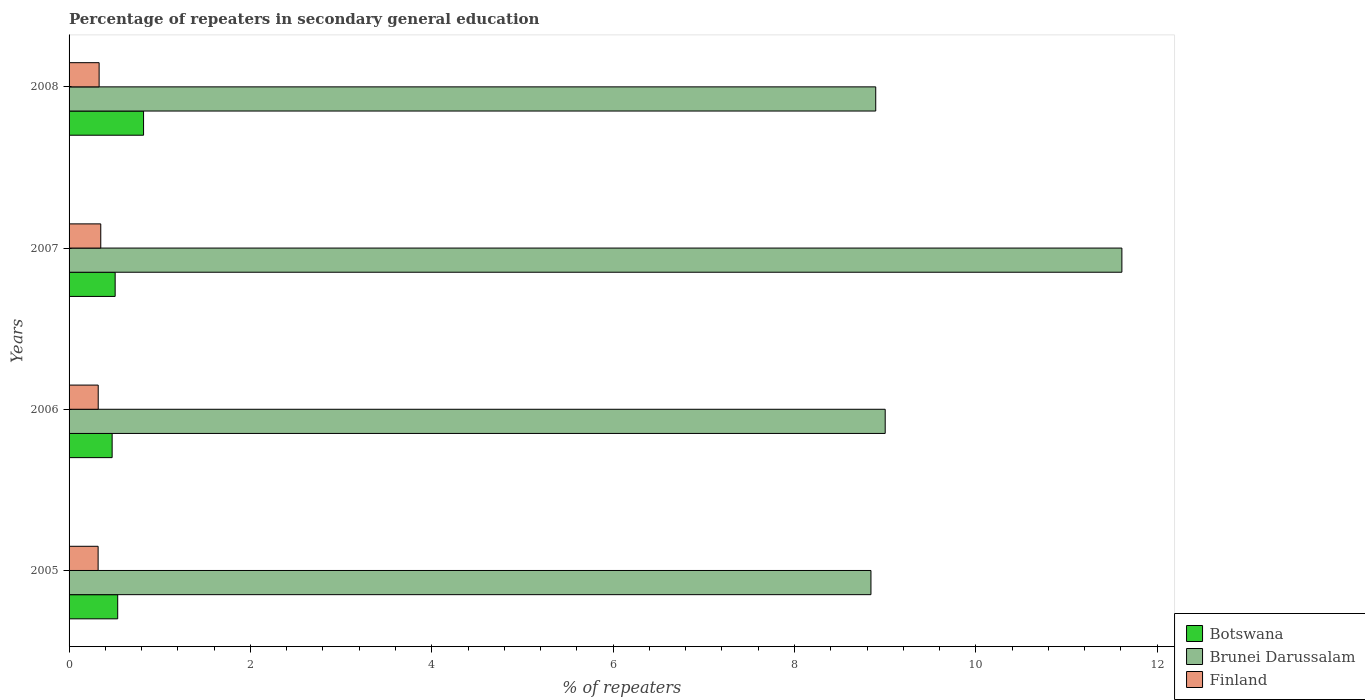How many different coloured bars are there?
Keep it short and to the point. 3. Are the number of bars on each tick of the Y-axis equal?
Your response must be concise. Yes. What is the label of the 3rd group of bars from the top?
Give a very brief answer. 2006. What is the percentage of repeaters in secondary general education in Botswana in 2005?
Give a very brief answer. 0.54. Across all years, what is the maximum percentage of repeaters in secondary general education in Brunei Darussalam?
Offer a very short reply. 11.61. Across all years, what is the minimum percentage of repeaters in secondary general education in Botswana?
Offer a terse response. 0.48. In which year was the percentage of repeaters in secondary general education in Botswana maximum?
Your answer should be compact. 2008. What is the total percentage of repeaters in secondary general education in Finland in the graph?
Your response must be concise. 1.32. What is the difference between the percentage of repeaters in secondary general education in Botswana in 2006 and that in 2008?
Make the answer very short. -0.35. What is the difference between the percentage of repeaters in secondary general education in Finland in 2005 and the percentage of repeaters in secondary general education in Brunei Darussalam in 2008?
Your answer should be compact. -8.58. What is the average percentage of repeaters in secondary general education in Brunei Darussalam per year?
Your response must be concise. 9.59. In the year 2008, what is the difference between the percentage of repeaters in secondary general education in Finland and percentage of repeaters in secondary general education in Botswana?
Offer a terse response. -0.49. What is the ratio of the percentage of repeaters in secondary general education in Finland in 2006 to that in 2007?
Give a very brief answer. 0.92. Is the difference between the percentage of repeaters in secondary general education in Finland in 2005 and 2006 greater than the difference between the percentage of repeaters in secondary general education in Botswana in 2005 and 2006?
Make the answer very short. No. What is the difference between the highest and the second highest percentage of repeaters in secondary general education in Finland?
Offer a very short reply. 0.02. What is the difference between the highest and the lowest percentage of repeaters in secondary general education in Finland?
Your answer should be compact. 0.03. In how many years, is the percentage of repeaters in secondary general education in Botswana greater than the average percentage of repeaters in secondary general education in Botswana taken over all years?
Provide a short and direct response. 1. Is the sum of the percentage of repeaters in secondary general education in Finland in 2005 and 2007 greater than the maximum percentage of repeaters in secondary general education in Brunei Darussalam across all years?
Your answer should be very brief. No. What does the 3rd bar from the top in 2006 represents?
Ensure brevity in your answer.  Botswana. What does the 1st bar from the bottom in 2006 represents?
Offer a terse response. Botswana. Are all the bars in the graph horizontal?
Make the answer very short. Yes. Are the values on the major ticks of X-axis written in scientific E-notation?
Provide a short and direct response. No. Does the graph contain grids?
Your answer should be very brief. No. How many legend labels are there?
Make the answer very short. 3. How are the legend labels stacked?
Offer a very short reply. Vertical. What is the title of the graph?
Your response must be concise. Percentage of repeaters in secondary general education. Does "Curacao" appear as one of the legend labels in the graph?
Offer a very short reply. No. What is the label or title of the X-axis?
Provide a short and direct response. % of repeaters. What is the % of repeaters of Botswana in 2005?
Provide a succinct answer. 0.54. What is the % of repeaters of Brunei Darussalam in 2005?
Offer a terse response. 8.84. What is the % of repeaters of Finland in 2005?
Keep it short and to the point. 0.32. What is the % of repeaters of Botswana in 2006?
Provide a succinct answer. 0.48. What is the % of repeaters in Brunei Darussalam in 2006?
Keep it short and to the point. 9. What is the % of repeaters in Finland in 2006?
Keep it short and to the point. 0.32. What is the % of repeaters of Botswana in 2007?
Provide a succinct answer. 0.51. What is the % of repeaters of Brunei Darussalam in 2007?
Offer a very short reply. 11.61. What is the % of repeaters in Finland in 2007?
Your response must be concise. 0.35. What is the % of repeaters in Botswana in 2008?
Ensure brevity in your answer.  0.82. What is the % of repeaters in Brunei Darussalam in 2008?
Provide a succinct answer. 8.9. What is the % of repeaters of Finland in 2008?
Offer a very short reply. 0.33. Across all years, what is the maximum % of repeaters in Botswana?
Your response must be concise. 0.82. Across all years, what is the maximum % of repeaters in Brunei Darussalam?
Provide a succinct answer. 11.61. Across all years, what is the maximum % of repeaters in Finland?
Your answer should be very brief. 0.35. Across all years, what is the minimum % of repeaters of Botswana?
Your answer should be compact. 0.48. Across all years, what is the minimum % of repeaters of Brunei Darussalam?
Your answer should be compact. 8.84. Across all years, what is the minimum % of repeaters in Finland?
Your answer should be compact. 0.32. What is the total % of repeaters in Botswana in the graph?
Provide a short and direct response. 2.34. What is the total % of repeaters in Brunei Darussalam in the graph?
Provide a short and direct response. 38.35. What is the total % of repeaters in Finland in the graph?
Ensure brevity in your answer.  1.32. What is the difference between the % of repeaters in Botswana in 2005 and that in 2006?
Make the answer very short. 0.06. What is the difference between the % of repeaters of Brunei Darussalam in 2005 and that in 2006?
Ensure brevity in your answer.  -0.16. What is the difference between the % of repeaters in Finland in 2005 and that in 2006?
Make the answer very short. -0. What is the difference between the % of repeaters of Botswana in 2005 and that in 2007?
Make the answer very short. 0.03. What is the difference between the % of repeaters in Brunei Darussalam in 2005 and that in 2007?
Keep it short and to the point. -2.77. What is the difference between the % of repeaters in Finland in 2005 and that in 2007?
Your answer should be very brief. -0.03. What is the difference between the % of repeaters of Botswana in 2005 and that in 2008?
Provide a succinct answer. -0.29. What is the difference between the % of repeaters in Brunei Darussalam in 2005 and that in 2008?
Your answer should be very brief. -0.05. What is the difference between the % of repeaters in Finland in 2005 and that in 2008?
Make the answer very short. -0.01. What is the difference between the % of repeaters in Botswana in 2006 and that in 2007?
Your answer should be very brief. -0.03. What is the difference between the % of repeaters in Brunei Darussalam in 2006 and that in 2007?
Provide a succinct answer. -2.61. What is the difference between the % of repeaters in Finland in 2006 and that in 2007?
Offer a terse response. -0.03. What is the difference between the % of repeaters of Botswana in 2006 and that in 2008?
Provide a short and direct response. -0.35. What is the difference between the % of repeaters of Brunei Darussalam in 2006 and that in 2008?
Offer a terse response. 0.1. What is the difference between the % of repeaters of Finland in 2006 and that in 2008?
Ensure brevity in your answer.  -0.01. What is the difference between the % of repeaters in Botswana in 2007 and that in 2008?
Keep it short and to the point. -0.31. What is the difference between the % of repeaters in Brunei Darussalam in 2007 and that in 2008?
Provide a succinct answer. 2.71. What is the difference between the % of repeaters of Finland in 2007 and that in 2008?
Your response must be concise. 0.02. What is the difference between the % of repeaters in Botswana in 2005 and the % of repeaters in Brunei Darussalam in 2006?
Your answer should be very brief. -8.46. What is the difference between the % of repeaters in Botswana in 2005 and the % of repeaters in Finland in 2006?
Offer a terse response. 0.21. What is the difference between the % of repeaters of Brunei Darussalam in 2005 and the % of repeaters of Finland in 2006?
Keep it short and to the point. 8.52. What is the difference between the % of repeaters in Botswana in 2005 and the % of repeaters in Brunei Darussalam in 2007?
Provide a succinct answer. -11.07. What is the difference between the % of repeaters in Botswana in 2005 and the % of repeaters in Finland in 2007?
Your answer should be compact. 0.19. What is the difference between the % of repeaters in Brunei Darussalam in 2005 and the % of repeaters in Finland in 2007?
Give a very brief answer. 8.49. What is the difference between the % of repeaters in Botswana in 2005 and the % of repeaters in Brunei Darussalam in 2008?
Your answer should be very brief. -8.36. What is the difference between the % of repeaters of Botswana in 2005 and the % of repeaters of Finland in 2008?
Offer a terse response. 0.2. What is the difference between the % of repeaters of Brunei Darussalam in 2005 and the % of repeaters of Finland in 2008?
Provide a succinct answer. 8.51. What is the difference between the % of repeaters of Botswana in 2006 and the % of repeaters of Brunei Darussalam in 2007?
Ensure brevity in your answer.  -11.14. What is the difference between the % of repeaters of Botswana in 2006 and the % of repeaters of Finland in 2007?
Keep it short and to the point. 0.13. What is the difference between the % of repeaters of Brunei Darussalam in 2006 and the % of repeaters of Finland in 2007?
Offer a terse response. 8.65. What is the difference between the % of repeaters of Botswana in 2006 and the % of repeaters of Brunei Darussalam in 2008?
Provide a short and direct response. -8.42. What is the difference between the % of repeaters of Botswana in 2006 and the % of repeaters of Finland in 2008?
Offer a very short reply. 0.14. What is the difference between the % of repeaters in Brunei Darussalam in 2006 and the % of repeaters in Finland in 2008?
Make the answer very short. 8.67. What is the difference between the % of repeaters in Botswana in 2007 and the % of repeaters in Brunei Darussalam in 2008?
Provide a succinct answer. -8.39. What is the difference between the % of repeaters in Botswana in 2007 and the % of repeaters in Finland in 2008?
Your response must be concise. 0.18. What is the difference between the % of repeaters of Brunei Darussalam in 2007 and the % of repeaters of Finland in 2008?
Offer a terse response. 11.28. What is the average % of repeaters in Botswana per year?
Your answer should be very brief. 0.59. What is the average % of repeaters of Brunei Darussalam per year?
Keep it short and to the point. 9.59. What is the average % of repeaters of Finland per year?
Offer a very short reply. 0.33. In the year 2005, what is the difference between the % of repeaters in Botswana and % of repeaters in Brunei Darussalam?
Your response must be concise. -8.31. In the year 2005, what is the difference between the % of repeaters in Botswana and % of repeaters in Finland?
Ensure brevity in your answer.  0.22. In the year 2005, what is the difference between the % of repeaters in Brunei Darussalam and % of repeaters in Finland?
Make the answer very short. 8.52. In the year 2006, what is the difference between the % of repeaters of Botswana and % of repeaters of Brunei Darussalam?
Ensure brevity in your answer.  -8.53. In the year 2006, what is the difference between the % of repeaters in Botswana and % of repeaters in Finland?
Your response must be concise. 0.15. In the year 2006, what is the difference between the % of repeaters of Brunei Darussalam and % of repeaters of Finland?
Offer a very short reply. 8.68. In the year 2007, what is the difference between the % of repeaters of Botswana and % of repeaters of Brunei Darussalam?
Give a very brief answer. -11.1. In the year 2007, what is the difference between the % of repeaters in Botswana and % of repeaters in Finland?
Keep it short and to the point. 0.16. In the year 2007, what is the difference between the % of repeaters of Brunei Darussalam and % of repeaters of Finland?
Your answer should be compact. 11.26. In the year 2008, what is the difference between the % of repeaters in Botswana and % of repeaters in Brunei Darussalam?
Keep it short and to the point. -8.07. In the year 2008, what is the difference between the % of repeaters in Botswana and % of repeaters in Finland?
Provide a succinct answer. 0.49. In the year 2008, what is the difference between the % of repeaters in Brunei Darussalam and % of repeaters in Finland?
Provide a short and direct response. 8.56. What is the ratio of the % of repeaters of Botswana in 2005 to that in 2006?
Provide a short and direct response. 1.13. What is the ratio of the % of repeaters in Brunei Darussalam in 2005 to that in 2006?
Provide a succinct answer. 0.98. What is the ratio of the % of repeaters in Botswana in 2005 to that in 2007?
Provide a short and direct response. 1.06. What is the ratio of the % of repeaters in Brunei Darussalam in 2005 to that in 2007?
Provide a short and direct response. 0.76. What is the ratio of the % of repeaters in Finland in 2005 to that in 2007?
Make the answer very short. 0.92. What is the ratio of the % of repeaters of Botswana in 2005 to that in 2008?
Your answer should be compact. 0.65. What is the ratio of the % of repeaters in Finland in 2005 to that in 2008?
Your answer should be compact. 0.97. What is the ratio of the % of repeaters of Botswana in 2006 to that in 2007?
Offer a very short reply. 0.93. What is the ratio of the % of repeaters of Brunei Darussalam in 2006 to that in 2007?
Give a very brief answer. 0.78. What is the ratio of the % of repeaters of Finland in 2006 to that in 2007?
Offer a terse response. 0.92. What is the ratio of the % of repeaters in Botswana in 2006 to that in 2008?
Provide a succinct answer. 0.58. What is the ratio of the % of repeaters of Brunei Darussalam in 2006 to that in 2008?
Your response must be concise. 1.01. What is the ratio of the % of repeaters in Finland in 2006 to that in 2008?
Keep it short and to the point. 0.97. What is the ratio of the % of repeaters of Botswana in 2007 to that in 2008?
Give a very brief answer. 0.62. What is the ratio of the % of repeaters in Brunei Darussalam in 2007 to that in 2008?
Your response must be concise. 1.31. What is the ratio of the % of repeaters in Finland in 2007 to that in 2008?
Make the answer very short. 1.05. What is the difference between the highest and the second highest % of repeaters in Botswana?
Give a very brief answer. 0.29. What is the difference between the highest and the second highest % of repeaters in Brunei Darussalam?
Provide a short and direct response. 2.61. What is the difference between the highest and the second highest % of repeaters in Finland?
Ensure brevity in your answer.  0.02. What is the difference between the highest and the lowest % of repeaters in Botswana?
Provide a short and direct response. 0.35. What is the difference between the highest and the lowest % of repeaters of Brunei Darussalam?
Offer a very short reply. 2.77. What is the difference between the highest and the lowest % of repeaters in Finland?
Your response must be concise. 0.03. 